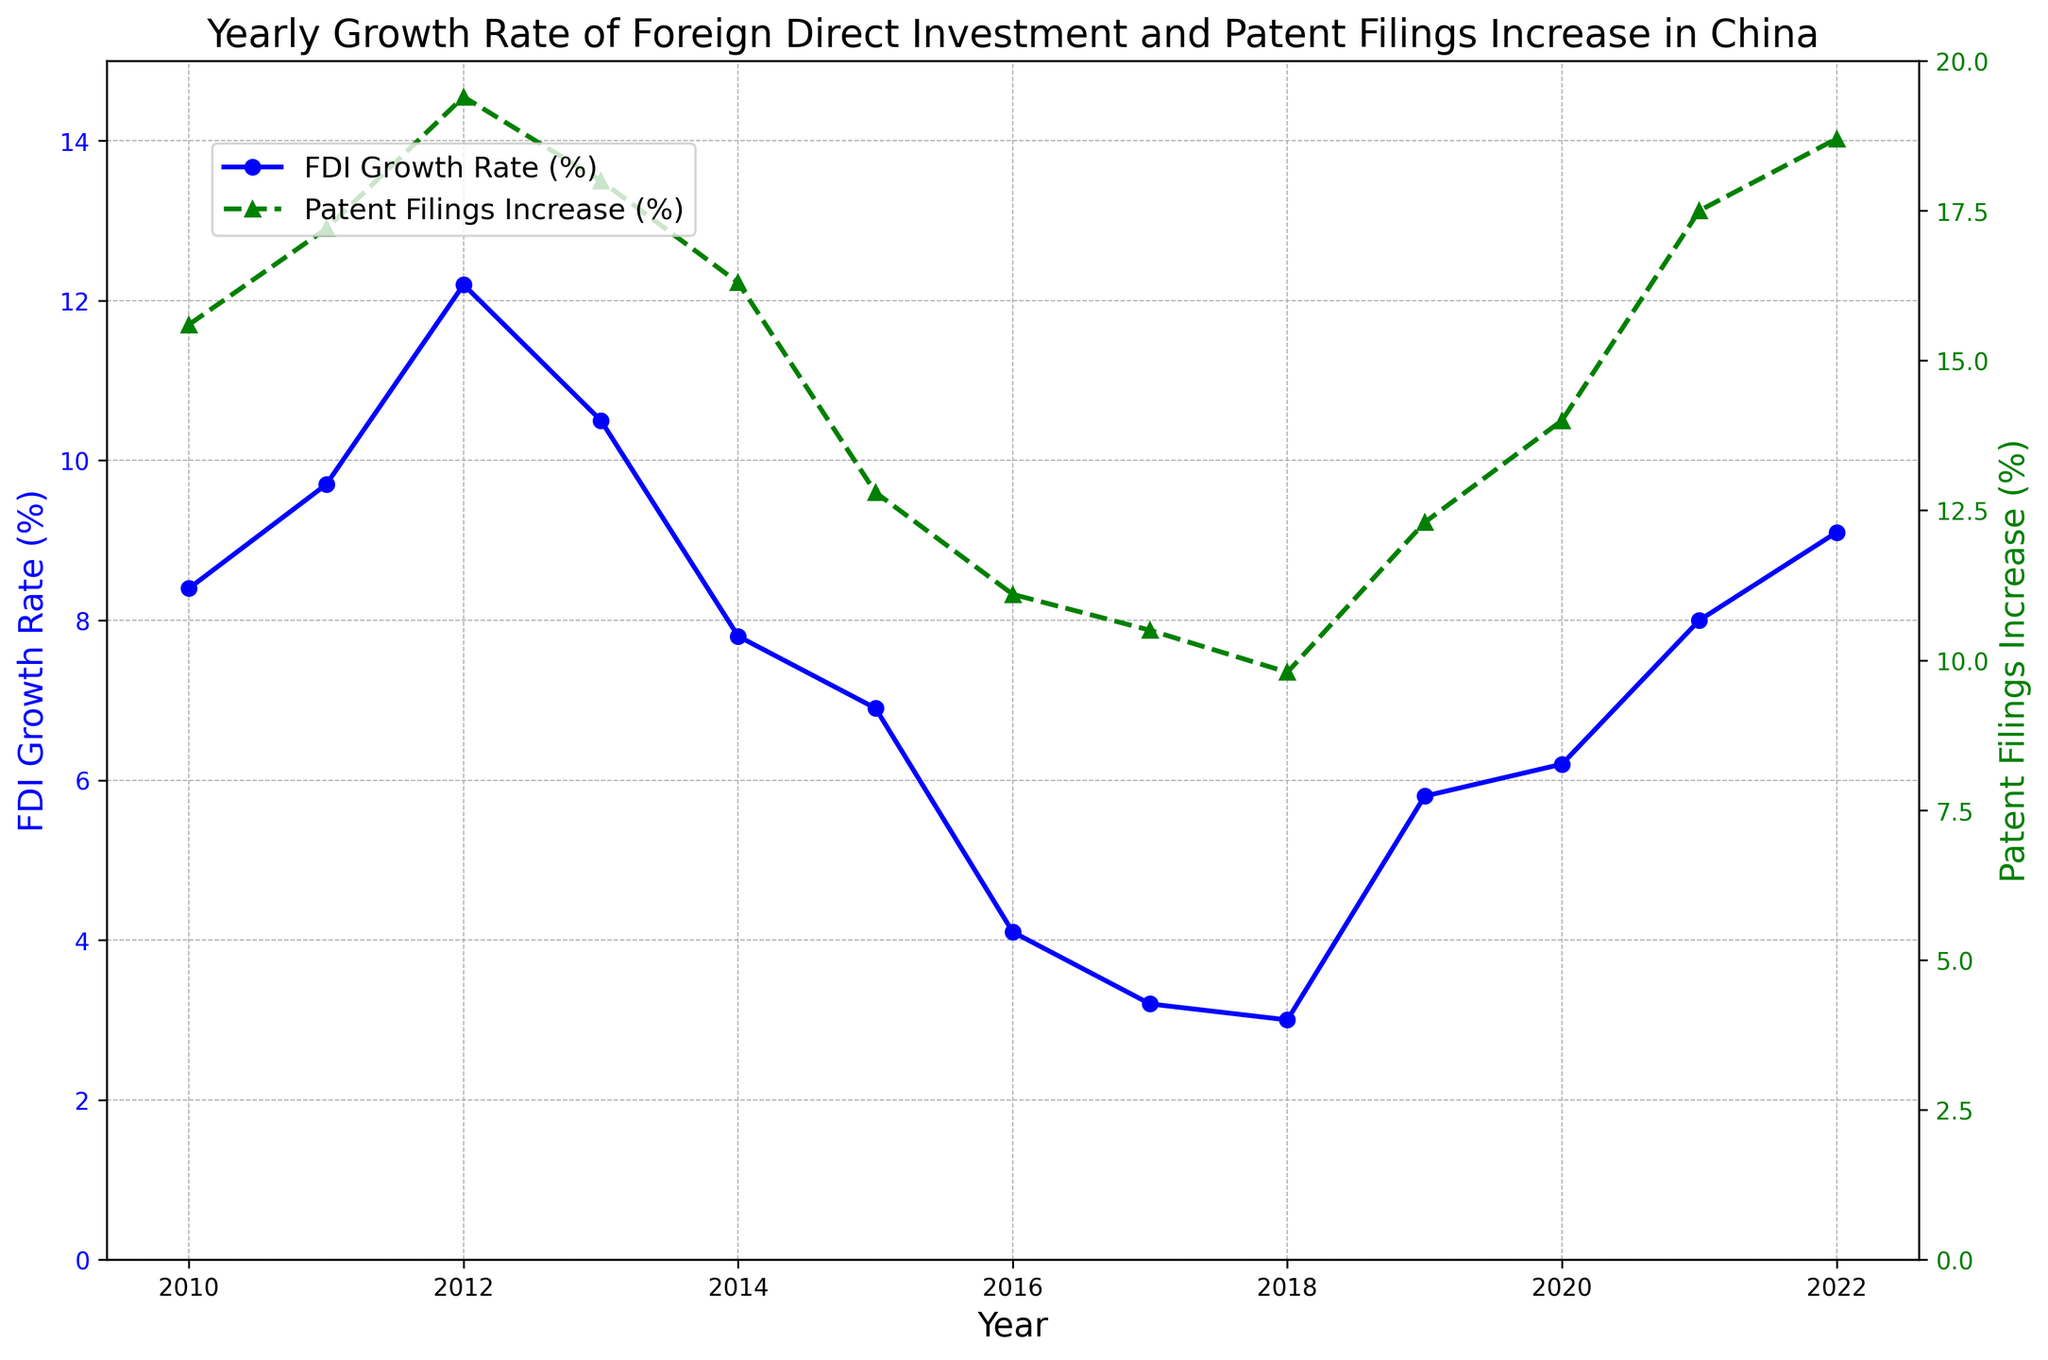What is the overall trend in the FDI Growth Rate from 2010 to 2022? The FDI Growth Rate shows a general declining trend from 2010 to 2018, with a slight recovery from 2019 to 2022. Specifically, it starts at 8.4% in 2010, decreases to a low of 3.0% in 2018, and then increases to 9.1% by 2022.
Answer: Declining, then slight recovery Does the Patent Filings Increase (%) follow the same trend as the FDI Growth Rate (%) from 2010 to 2022? Both metrics exhibit similar trends, showing high values initially, a period of decline, and then a resurgence towards the end. For instance, both metrics drop during the 2015-2018 period and then rise again through to 2022.
Answer: Yes In which year was the gap between FDI Growth Rate (%) and Patent Filings Increase (%) the largest? To find the maximum gap, we can look at the differences year by year. The largest gap appears in 2012, where FDI Growth Rate is 12.2% and Patent Filings Increase is 19.4%, making the gap 7.2%.
Answer: 2012 What is the average FDI Growth Rate (%) over the period from 2010 to 2022? Adding the FDI Growth Rates from each year and dividing by the number of years: (8.4 + 9.7 + 12.2 + 10.5 + 7.8 + 6.9 + 4.1 + 3.2 + 3.0 + 5.8 + 6.2 + 8.0 + 9.1) / 13 = 7.1%.
Answer: 7.1% Between 2015 and 2022, which year had the highest increase in Patent Filings (%)? From visual inspection of the green line, the highest Patent Filings Increase between these years is in 2022, with a rate of 18.7%.
Answer: 2022 What was the FDI Growth Rate (%) difference between 2013 and 2016? FDI Growth Rate in 2013 is 10.5% and in 2016 is 4.1%. Subtracting the two values: 10.5 - 4.1 = 6.4%.
Answer: 6.4% Was there any year where both the FDI Growth Rate (%) and Patent Filings Increase (%) were the same or very close to each other? From visual inspection, there was no explicit year where both rates were exactly equal or very close. The smallest gap appears in 2020, but they are still distinct at 6.2% for FDI and 14.0% for Patent Filings.
Answer: No Which year experienced the steepest decline in FDI Growth Rate (%) from the previous year? The steepest decline can be identified by visually inspecting the blue line for the sharpest drop. The year 2013 to 2014 has a drop from 10.5% to 7.8%, which is the largest decline of 2.7 percentage points.
Answer: 2013 to 2014 Compare the rate of increase in Patent Filings (%) to the rate of increase in FDI (%) from 2019 to 2022. Calculate the difference for both metrics from 2019 to 2022: For FDI: 9.1% - 5.8% = 3.3%; For Patent Filings: 18.7% - 12.3% = 6.4%. The rate of increase for Patent Filings is higher than that for FDI.
Answer: Patent filings increase more What was the overall trend in Patent Filings Increase (%) from 2010 to 2022? The trend shows initial growth till 2012, a decline during 2015-2018, followed by an increasing trend till 2022. It starts at 15.6% in 2010, reaching a high of 19.4% in 2012, decreasing to 9.8% in 2018, and ending at 18.7% in 2022.
Answer: Growth, decline, then growth 